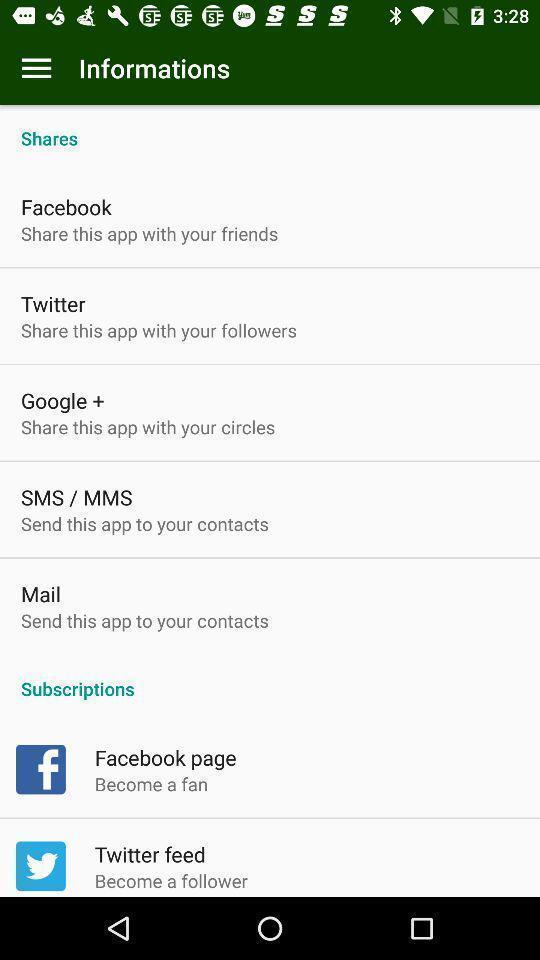What can you discern from this picture? Page displaying list of information options. 